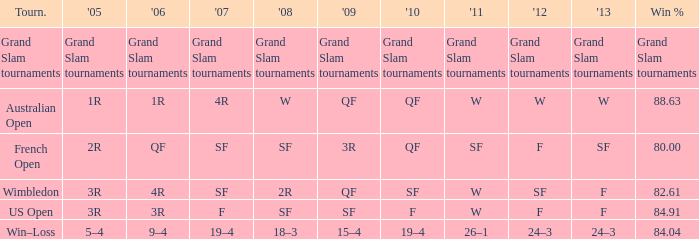When in 2008 that has a 2007 of f? SF. 